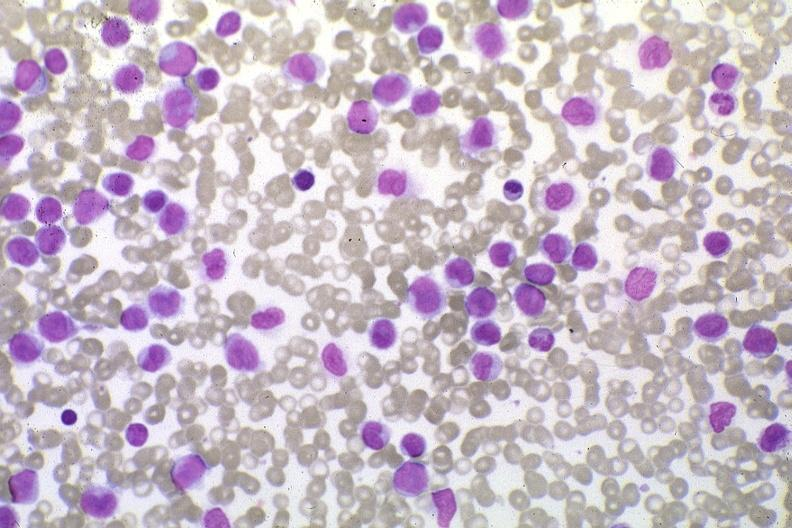what is present?
Answer the question using a single word or phrase. Acute monocytic leukemia 